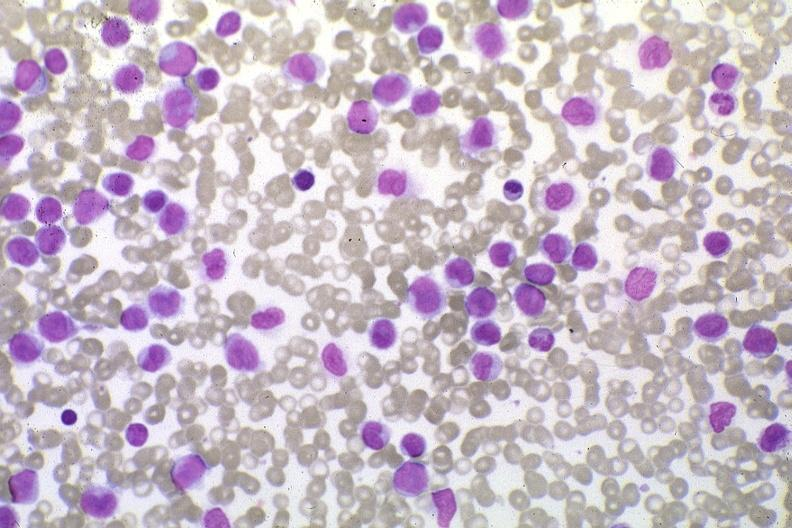what is present?
Answer the question using a single word or phrase. Acute monocytic leukemia 